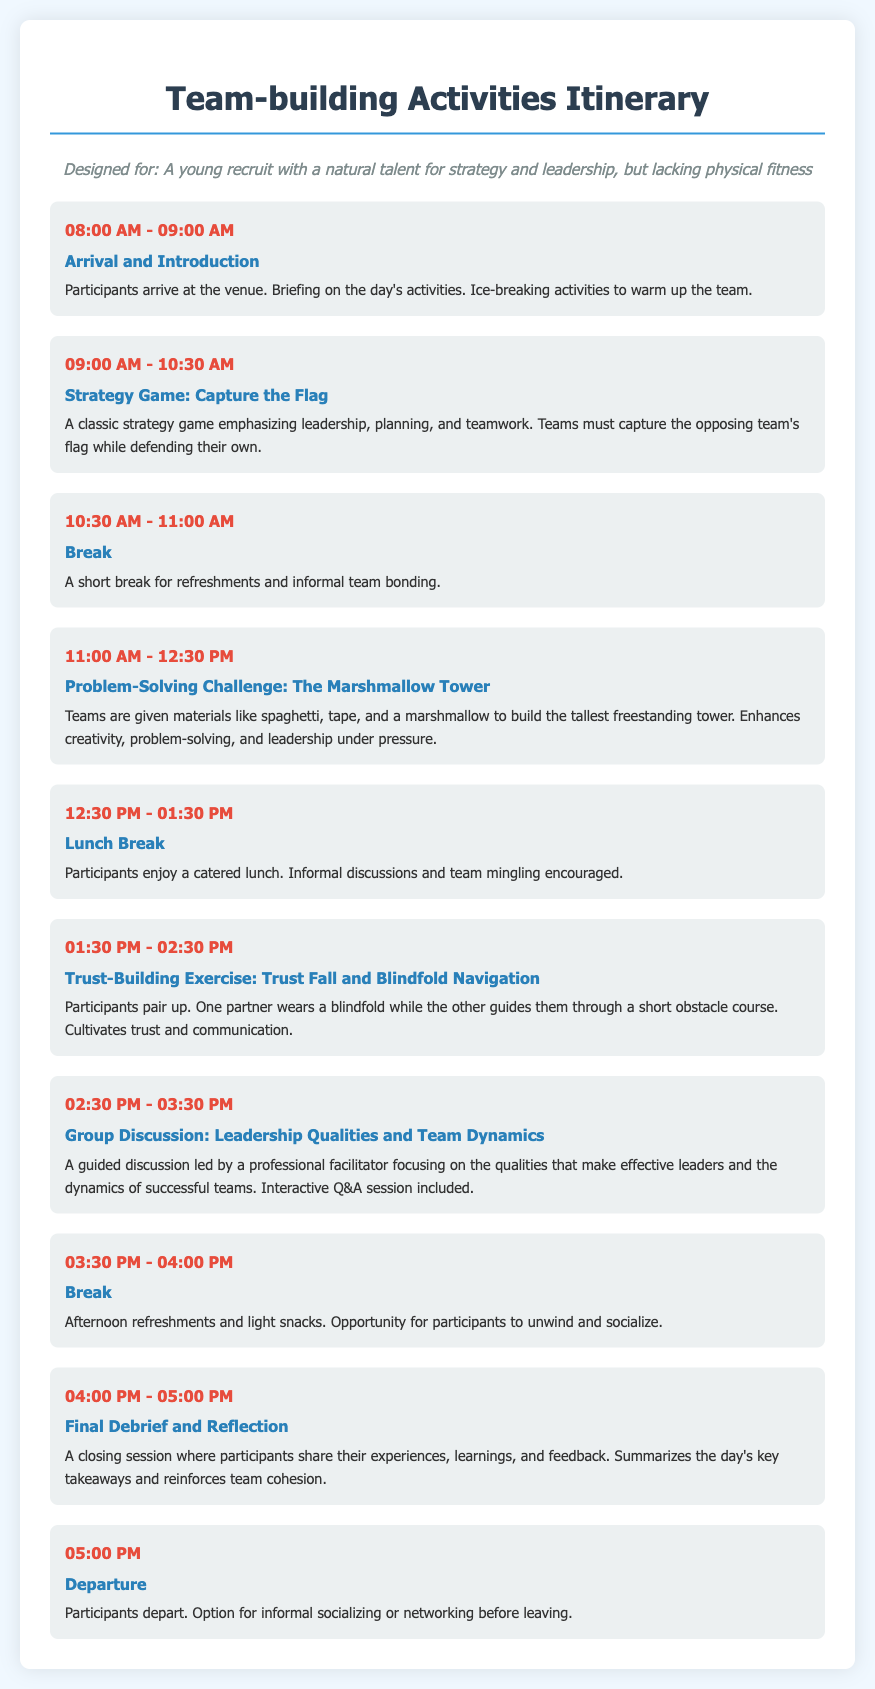what time does the team-building activities start? The activities start at 08:00 AM as indicated in the schedule.
Answer: 08:00 AM how long is the lunch break? The lunch break is from 12:30 PM to 01:30 PM, which is one hour long.
Answer: 01:00 hour what activity is scheduled after the break at 10:30 AM? After the break at 10:30 AM, the activity scheduled is the Problem-Solving Challenge.
Answer: Problem-Solving Challenge what is the focus of the Group Discussion scheduled at 02:30 PM? The Group Discussion focuses on Leadership Qualities and Team Dynamics, as stated in the description.
Answer: Leadership Qualities and Team Dynamics how many activities are there in total listed in the itinerary? There are a total of nine activities listed in the itinerary.
Answer: Nine what is the final activity before participants depart? The final activity before departure is the Final Debrief and Reflection.
Answer: Final Debrief and Reflection what materials are used in the Problem-Solving Challenge? The materials for the Problem-Solving Challenge are spaghetti, tape, and a marshmallow.
Answer: spaghetti, tape, marshmallow what type of exercise is the Trust-Building activity? The Trust-Building activity involves the Trust Fall and Blindfold Navigation as described.
Answer: Trust Fall and Blindfold Navigation what is emphasized in the Strategy Game? The Strategy Game emphasizes leadership, planning, and teamwork.
Answer: leadership, planning, teamwork 